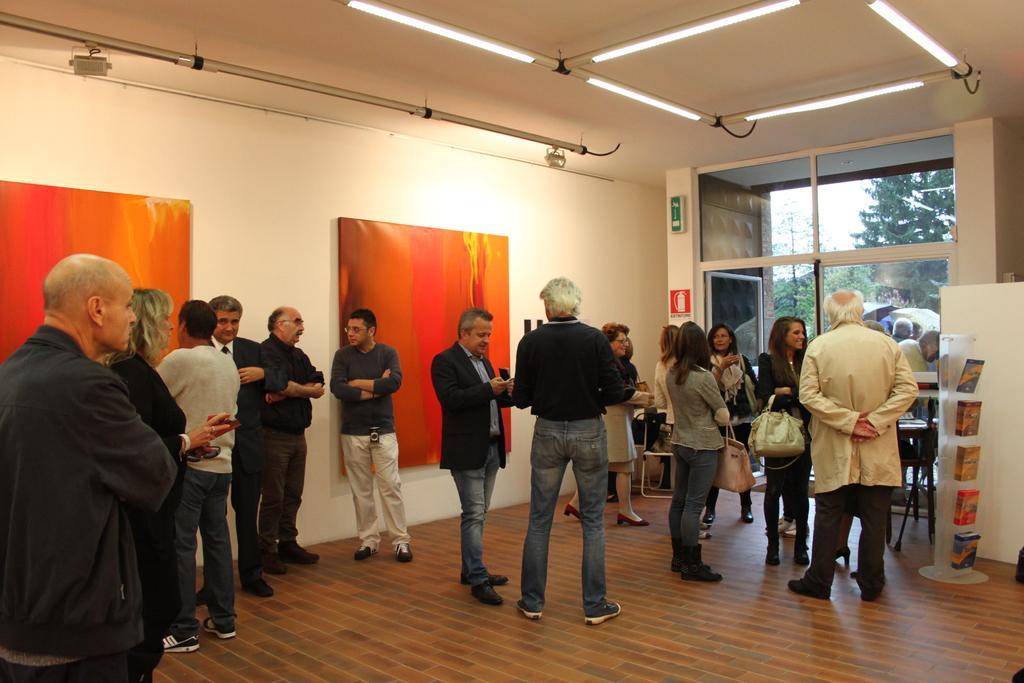Describe this image in one or two sentences. In this image we can see many people standing. Some are holding bags. One person is having a camera. In the back there is a wall with boards. On the ceiling there are lights. And there is a door. Near to the door there are sign boards. On the right side there is a stand with some items. Through the glass walls we can see trees and sky. 